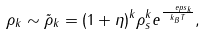<formula> <loc_0><loc_0><loc_500><loc_500>\rho _ { k } \sim \tilde { \rho } _ { k } = ( 1 + \eta ) ^ { k } \rho _ { s } ^ { k } e ^ { \frac { \ e p s _ { k } } { k _ { B } T } } ,</formula> 